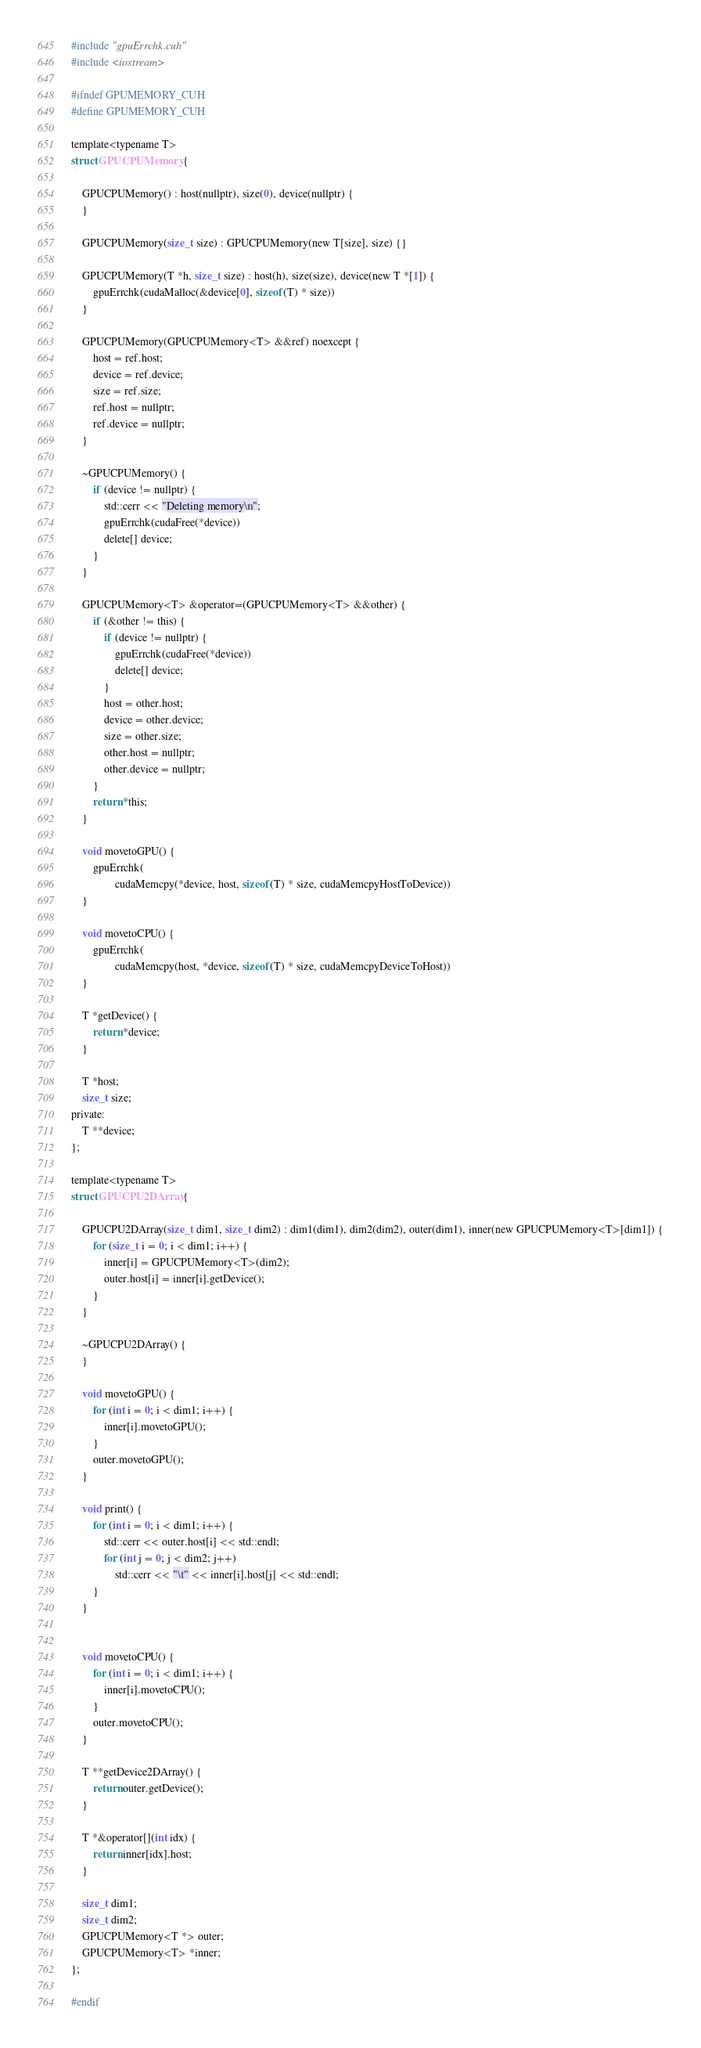<code> <loc_0><loc_0><loc_500><loc_500><_Cuda_>#include "gpuErrchk.cuh"
#include <iostream>

#ifndef GPUMEMORY_CUH
#define GPUMEMORY_CUH

template<typename T>
struct GPUCPUMemory {

    GPUCPUMemory() : host(nullptr), size(0), device(nullptr) {
    }

    GPUCPUMemory(size_t size) : GPUCPUMemory(new T[size], size) {}

    GPUCPUMemory(T *h, size_t size) : host(h), size(size), device(new T *[1]) {
        gpuErrchk(cudaMalloc(&device[0], sizeof(T) * size))
    }

    GPUCPUMemory(GPUCPUMemory<T> &&ref) noexcept {
        host = ref.host;
        device = ref.device;
        size = ref.size;
        ref.host = nullptr;
        ref.device = nullptr;
    }

    ~GPUCPUMemory() {
        if (device != nullptr) {
            std::cerr << "Deleting memory\n";
            gpuErrchk(cudaFree(*device))
            delete[] device;
        }
    }

    GPUCPUMemory<T> &operator=(GPUCPUMemory<T> &&other) {
        if (&other != this) {
            if (device != nullptr) {
                gpuErrchk(cudaFree(*device))
                delete[] device;
            }
            host = other.host;
            device = other.device;
            size = other.size;
            other.host = nullptr;
            other.device = nullptr;
        }
        return *this;
    }

    void movetoGPU() {
        gpuErrchk(
                cudaMemcpy(*device, host, sizeof(T) * size, cudaMemcpyHostToDevice))
    }

    void movetoCPU() {
        gpuErrchk(
                cudaMemcpy(host, *device, sizeof(T) * size, cudaMemcpyDeviceToHost))
    }

    T *getDevice() {
        return *device;
    }

    T *host;
    size_t size;
private:
    T **device;
};

template<typename T>
struct GPUCPU2DArray {

    GPUCPU2DArray(size_t dim1, size_t dim2) : dim1(dim1), dim2(dim2), outer(dim1), inner(new GPUCPUMemory<T>[dim1]) {
        for (size_t i = 0; i < dim1; i++) {
            inner[i] = GPUCPUMemory<T>(dim2);
            outer.host[i] = inner[i].getDevice();
        }
    }

    ~GPUCPU2DArray() {
    }

    void movetoGPU() {
        for (int i = 0; i < dim1; i++) {
            inner[i].movetoGPU();
        }
        outer.movetoGPU();
    }

    void print() {
        for (int i = 0; i < dim1; i++) {
            std::cerr << outer.host[i] << std::endl;
            for (int j = 0; j < dim2; j++)
                std::cerr << "\t" << inner[i].host[j] << std::endl;
        }
    }


    void movetoCPU() {
        for (int i = 0; i < dim1; i++) {
            inner[i].movetoCPU();
        }
        outer.movetoCPU();
    }

    T **getDevice2DArray() {
        return outer.getDevice();
    }

    T *&operator[](int idx) {
        return inner[idx].host;
    }

    size_t dim1;
    size_t dim2;
    GPUCPUMemory<T *> outer;
    GPUCPUMemory<T> *inner;
};

#endif</code> 